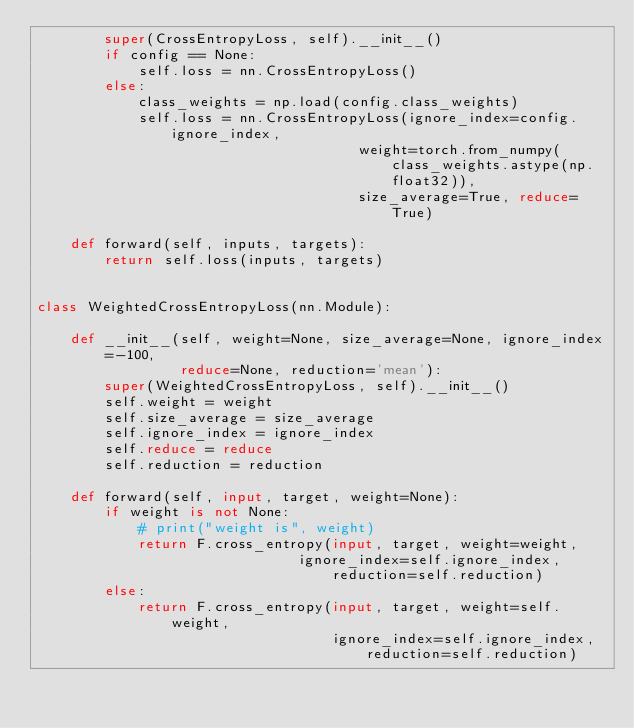<code> <loc_0><loc_0><loc_500><loc_500><_Python_>        super(CrossEntropyLoss, self).__init__()
        if config == None:
            self.loss = nn.CrossEntropyLoss()
        else:
            class_weights = np.load(config.class_weights)
            self.loss = nn.CrossEntropyLoss(ignore_index=config.ignore_index,
                                      weight=torch.from_numpy(class_weights.astype(np.float32)),
                                      size_average=True, reduce=True)

    def forward(self, inputs, targets):
        return self.loss(inputs, targets)


class WeightedCrossEntropyLoss(nn.Module):

    def __init__(self, weight=None, size_average=None, ignore_index=-100,
                 reduce=None, reduction='mean'):
        super(WeightedCrossEntropyLoss, self).__init__()
        self.weight = weight
        self.size_average = size_average
        self.ignore_index = ignore_index
        self.reduce = reduce
        self.reduction = reduction

    def forward(self, input, target, weight=None):
        if weight is not None:
            # print("weight is", weight)
            return F.cross_entropy(input, target, weight=weight,
                               ignore_index=self.ignore_index, reduction=self.reduction)
        else:
            return F.cross_entropy(input, target, weight=self.weight,
                                   ignore_index=self.ignore_index, reduction=self.reduction)
</code> 